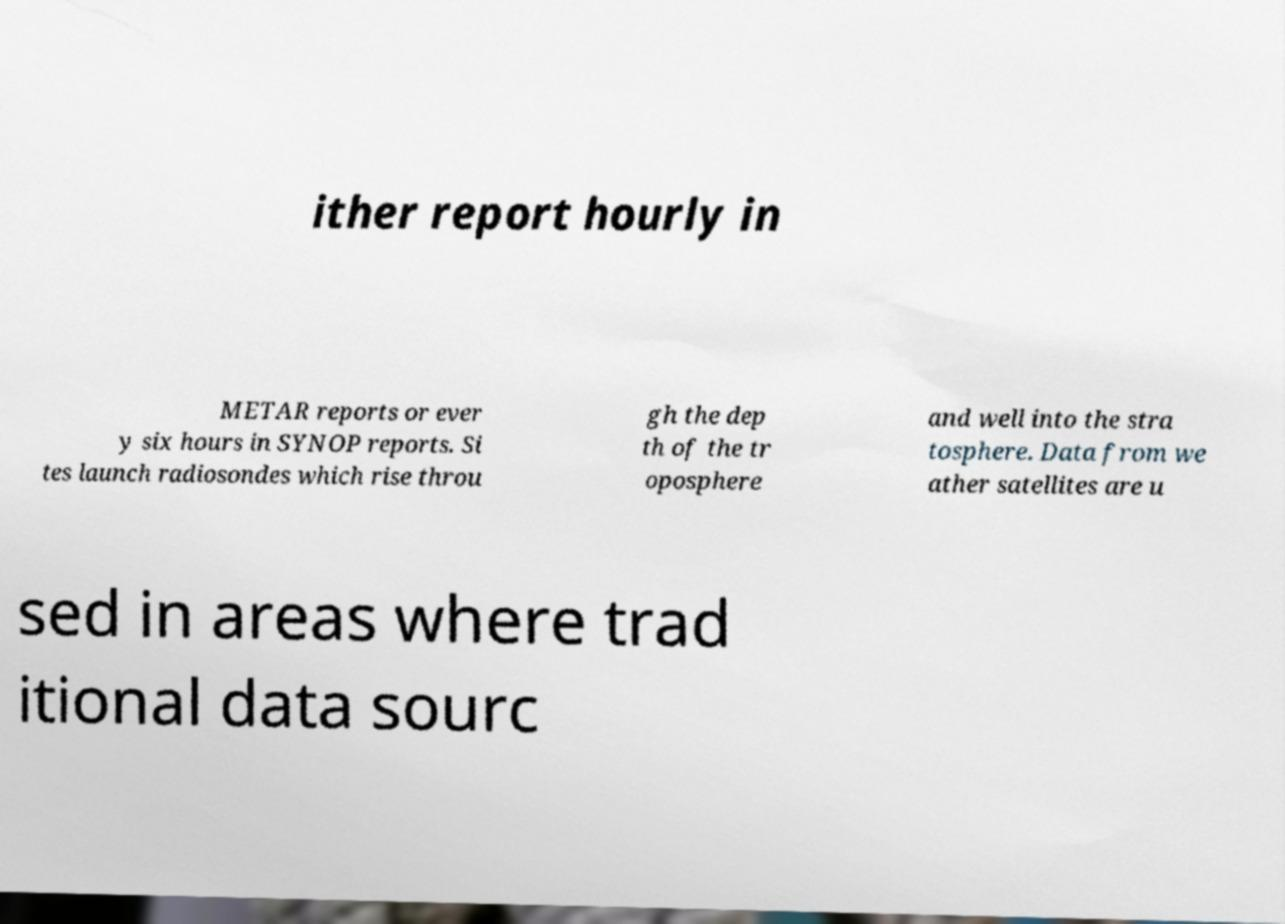Could you extract and type out the text from this image? ither report hourly in METAR reports or ever y six hours in SYNOP reports. Si tes launch radiosondes which rise throu gh the dep th of the tr oposphere and well into the stra tosphere. Data from we ather satellites are u sed in areas where trad itional data sourc 